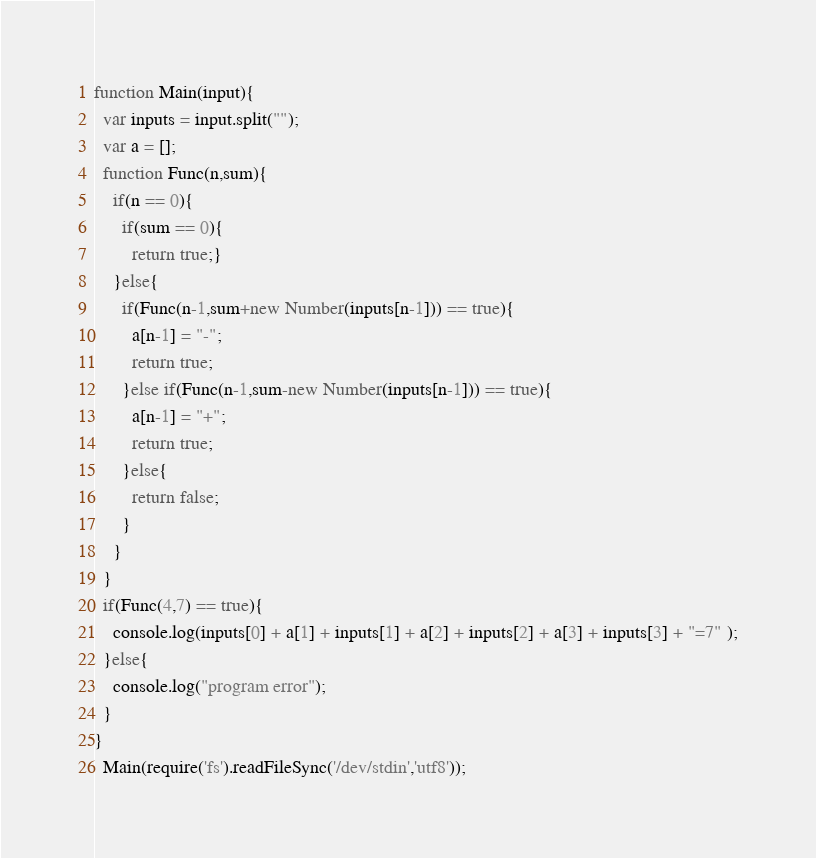<code> <loc_0><loc_0><loc_500><loc_500><_JavaScript_>function Main(input){
  var inputs = input.split("");
  var a = [];
  function Func(n,sum){
    if(n == 0){
      if(sum == 0){
        return true;}
    }else{
      if(Func(n-1,sum+new Number(inputs[n-1])) == true){
        a[n-1] = "-";
        return true;
      }else if(Func(n-1,sum-new Number(inputs[n-1])) == true){
        a[n-1] = "+";
        return true;
      }else{
        return false;
      }
    }
  }  
  if(Func(4,7) == true){
    console.log(inputs[0] + a[1] + inputs[1] + a[2] + inputs[2] + a[3] + inputs[3] + "=7" );
  }else{
    console.log("program error");
  }  
}
  Main(require('fs').readFileSync('/dev/stdin','utf8'));</code> 